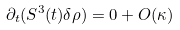Convert formula to latex. <formula><loc_0><loc_0><loc_500><loc_500>\partial _ { t } ( S ^ { 3 } ( t ) \delta \rho ) = 0 + O ( \kappa )</formula> 